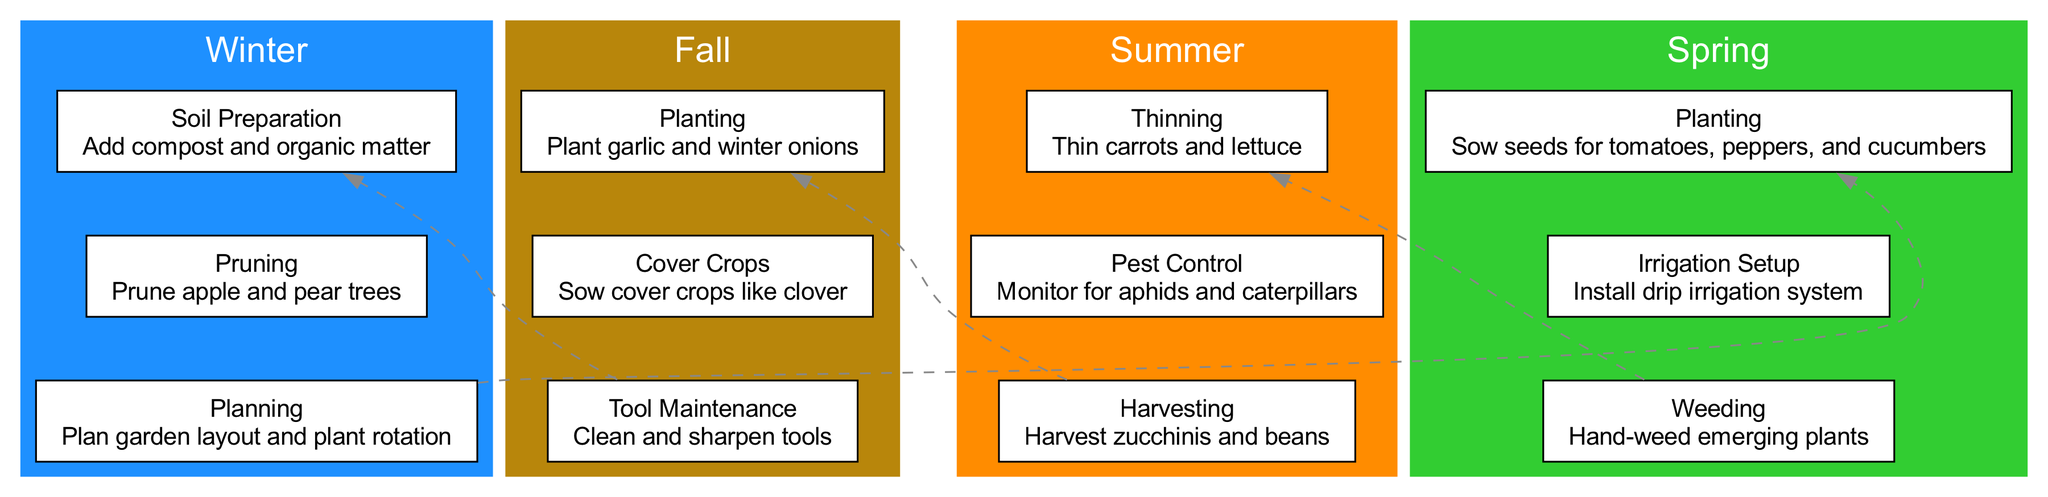What activities occur in Winter? The Winter section of the diagram lists three activities: Soil Preparation, Pruning, and Planning. Each of these activities is displayed within the Winter cluster of the diagram.
Answer: Soil Preparation, Pruning, Planning What is the timing for Planting activities? In the Spring section, the Planting activity is categorized under Early Spring, as indicated in the diagram.
Answer: Early Spring Which season includes Pest Control? Looking at the Summer section, Pest Control is explicitly listed as one of the activities that takes place during this season.
Answer: Summer What is the first activity listed for Fall? In the Fall section, Planting is the first listed activity, indicating it occurs in Early Fall. This is shown at the beginning of the Fall cluster.
Answer: Planting How many total activities are depicted in the Spring section? There are three activities listed in the Spring section: Planting, Irrigation Setup, and Weeding. Counting these activities gives a total of three.
Answer: 3 What activity follows Thinning in the Summer timeline? In the Summer section, after Thinning, the next listed activity is Pest Control, as per the flow of activities detailed in the diagram.
Answer: Pest Control Which two activities are located in the middle of Winter? The activity listed in the middle of Winter is Pruning, based on its placement within the Winter cluster, following Soil Preparation and preceding Planning.
Answer: Pruning Which color represents Fall in the diagram? The Fall section of the diagram is represented in Dark Goldenrod color, as indicated in the season color coding within the diagram.
Answer: Dark Goldenrod How many edges connect the seasons? The diagram features three dashed edges that connect the sections of Winter, Spring, Summer, and Fall, with each edge indicating a transition from one season to the next.
Answer: 3 